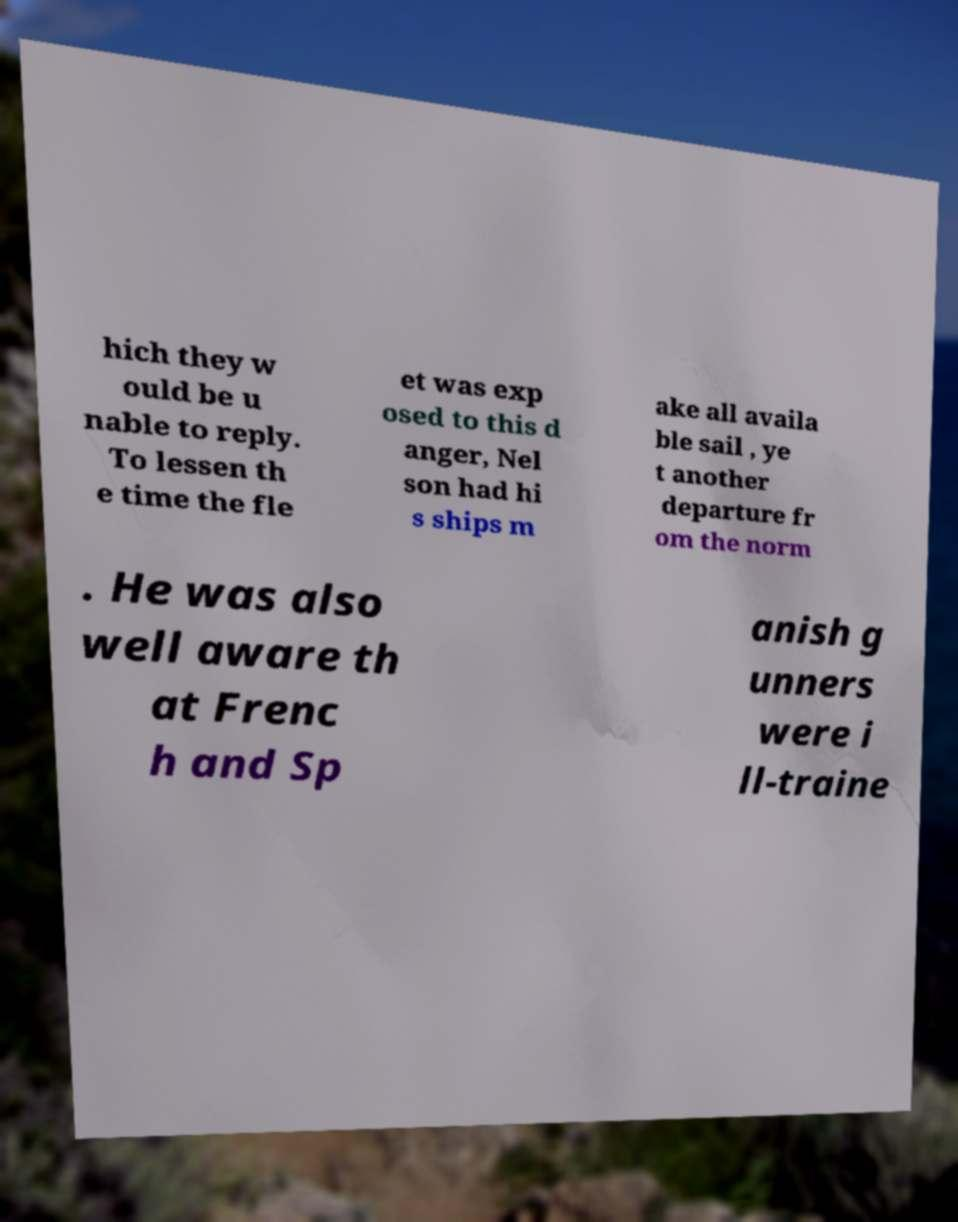Can you accurately transcribe the text from the provided image for me? hich they w ould be u nable to reply. To lessen th e time the fle et was exp osed to this d anger, Nel son had hi s ships m ake all availa ble sail , ye t another departure fr om the norm . He was also well aware th at Frenc h and Sp anish g unners were i ll-traine 